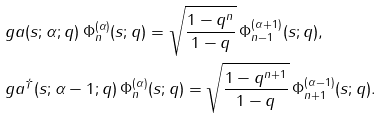Convert formula to latex. <formula><loc_0><loc_0><loc_500><loc_500>& \ g a ( s ; \alpha ; q ) \, \Phi _ { n } ^ { ( \alpha ) } ( s ; q ) = \sqrt { \frac { 1 - q ^ { n } } { 1 - q } } \, \Phi _ { n - 1 } ^ { ( \alpha + 1 ) } ( s ; q ) , \\ & \ g a ^ { \dag } ( s ; \alpha - 1 ; q ) \, \Phi _ { n } ^ { ( \alpha ) } ( s ; q ) = \sqrt { \frac { 1 - q ^ { n + 1 } } { 1 - q } } \, \Phi _ { n + 1 } ^ { ( \alpha - 1 ) } ( s ; q ) .</formula> 